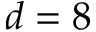Convert formula to latex. <formula><loc_0><loc_0><loc_500><loc_500>d = 8</formula> 